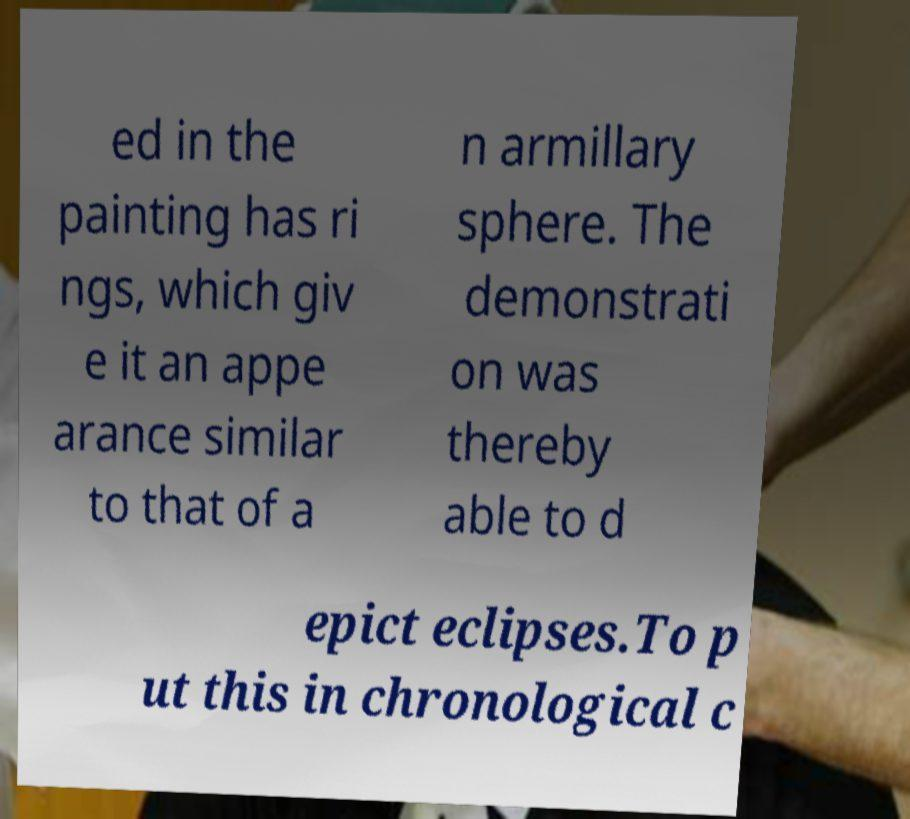Please identify and transcribe the text found in this image. ed in the painting has ri ngs, which giv e it an appe arance similar to that of a n armillary sphere. The demonstrati on was thereby able to d epict eclipses.To p ut this in chronological c 